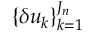<formula> <loc_0><loc_0><loc_500><loc_500>\{ \delta u _ { k } \} _ { k = 1 } ^ { J _ { n } }</formula> 